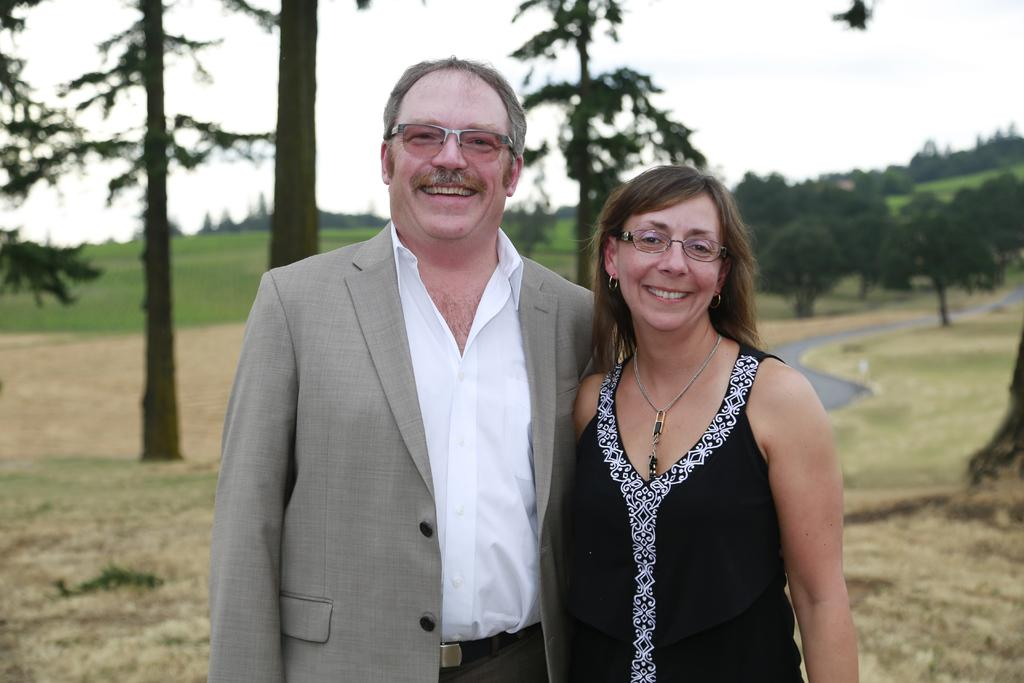Who is present in the image? There is a man and a lady in the image. What are the man and lady doing in the image? The man and lady are posing for a photograph. What can be seen in the background of the image? There are trees and a grassland in the background of the image. How is the background of the image depicted? The background is blurred. What type of jelly can be seen on the man's elbow in the image? There is no jelly or mention of an elbow in the image; the man and lady are posing for a photograph with a blurred background. 